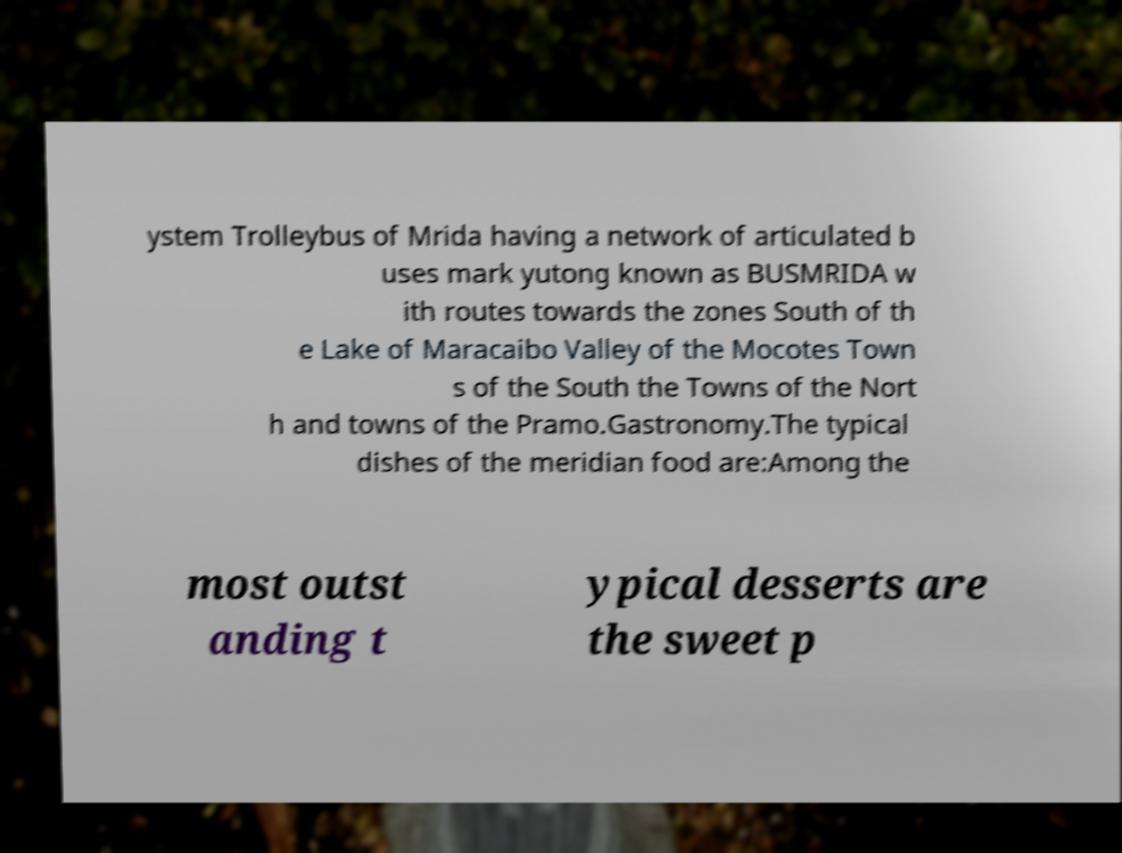There's text embedded in this image that I need extracted. Can you transcribe it verbatim? ystem Trolleybus of Mrida having a network of articulated b uses mark yutong known as BUSMRIDA w ith routes towards the zones South of th e Lake of Maracaibo Valley of the Mocotes Town s of the South the Towns of the Nort h and towns of the Pramo.Gastronomy.The typical dishes of the meridian food are:Among the most outst anding t ypical desserts are the sweet p 